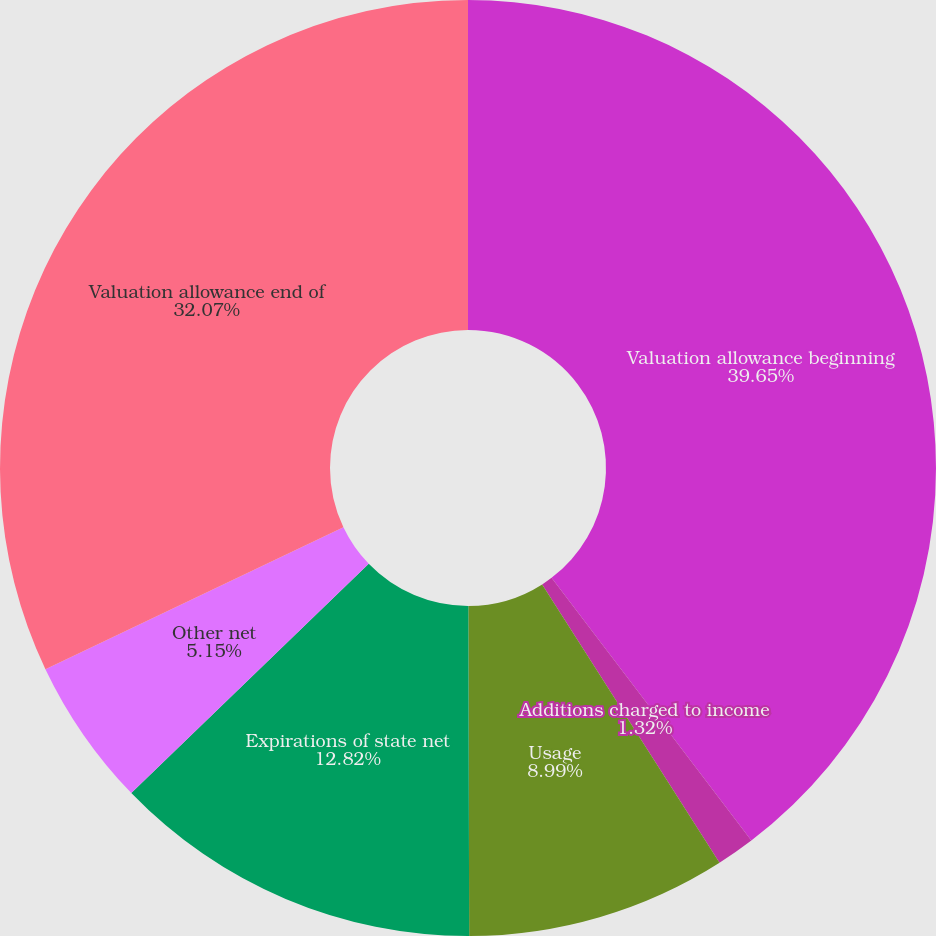Convert chart. <chart><loc_0><loc_0><loc_500><loc_500><pie_chart><fcel>Valuation allowance beginning<fcel>Additions charged to income<fcel>Usage<fcel>Expirations of state net<fcel>Other net<fcel>Valuation allowance end of<nl><fcel>39.65%<fcel>1.32%<fcel>8.99%<fcel>12.82%<fcel>5.15%<fcel>32.07%<nl></chart> 